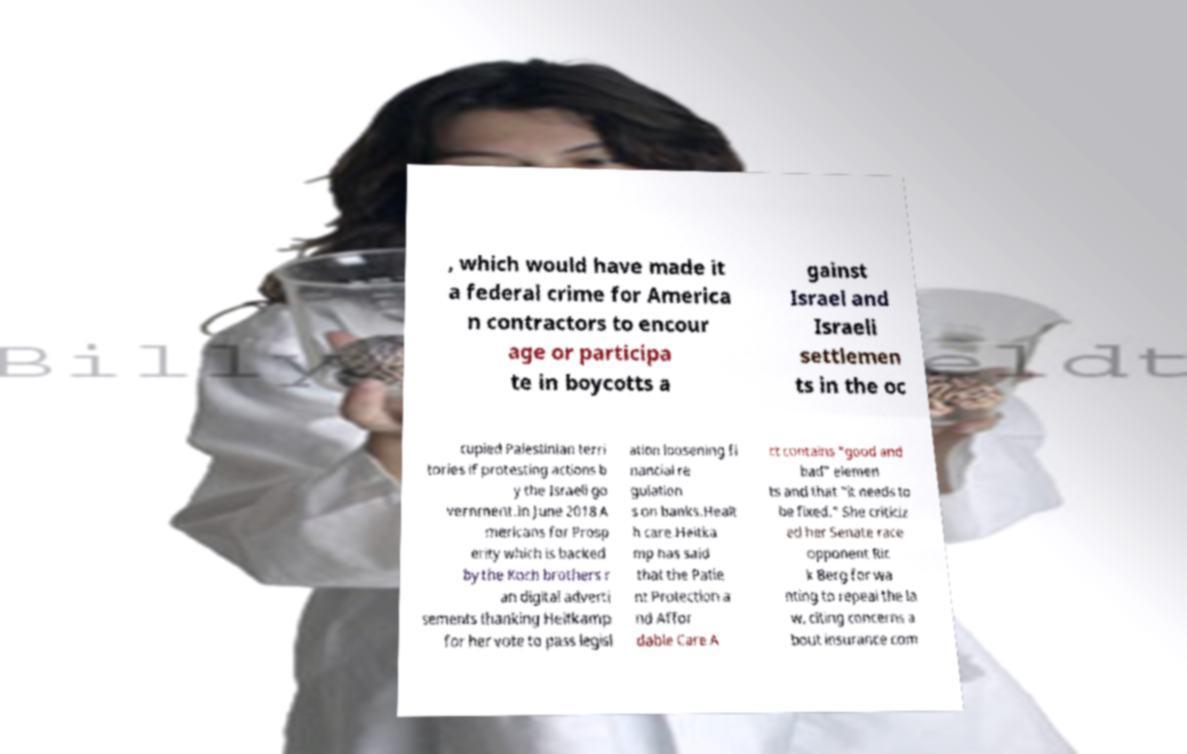Could you extract and type out the text from this image? , which would have made it a federal crime for America n contractors to encour age or participa te in boycotts a gainst Israel and Israeli settlemen ts in the oc cupied Palestinian terri tories if protesting actions b y the Israeli go vernment.In June 2018 A mericans for Prosp erity which is backed by the Koch brothers r an digital adverti sements thanking Heitkamp for her vote to pass legisl ation loosening fi nancial re gulation s on banks.Healt h care.Heitka mp has said that the Patie nt Protection a nd Affor dable Care A ct contains "good and bad" elemen ts and that "it needs to be fixed." She criticiz ed her Senate race opponent Ric k Berg for wa nting to repeal the la w, citing concerns a bout insurance com 